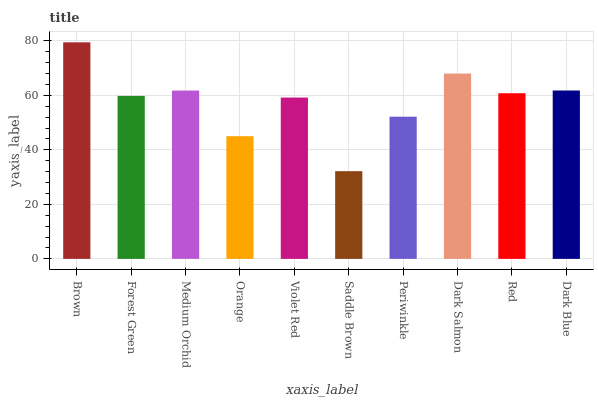Is Forest Green the minimum?
Answer yes or no. No. Is Forest Green the maximum?
Answer yes or no. No. Is Brown greater than Forest Green?
Answer yes or no. Yes. Is Forest Green less than Brown?
Answer yes or no. Yes. Is Forest Green greater than Brown?
Answer yes or no. No. Is Brown less than Forest Green?
Answer yes or no. No. Is Red the high median?
Answer yes or no. Yes. Is Forest Green the low median?
Answer yes or no. Yes. Is Dark Blue the high median?
Answer yes or no. No. Is Saddle Brown the low median?
Answer yes or no. No. 